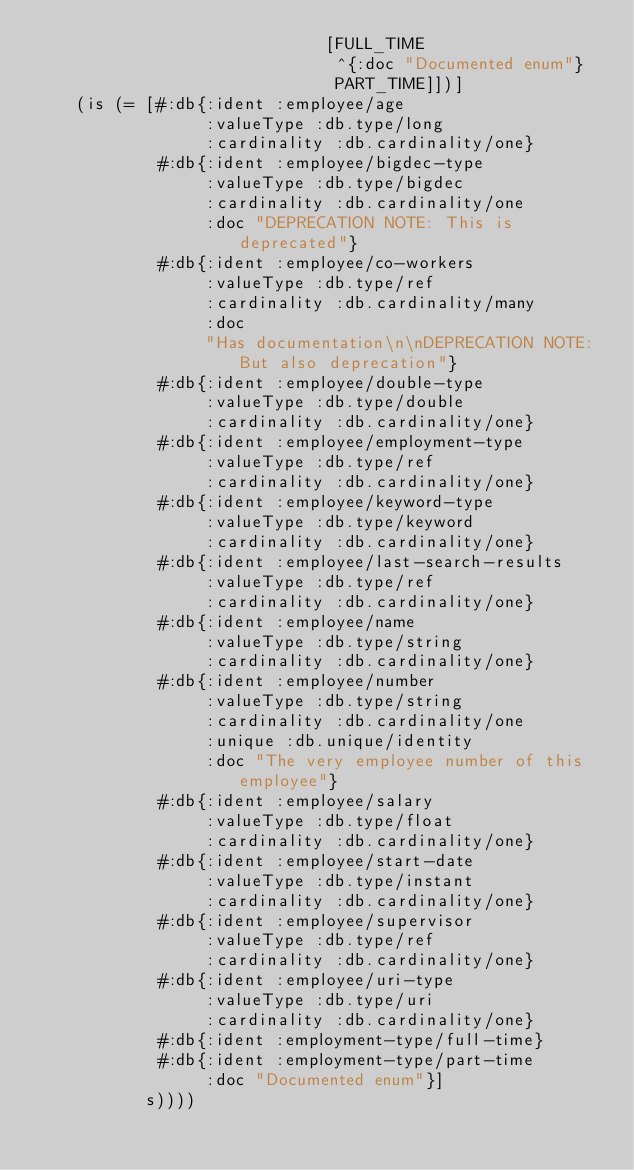Convert code to text. <code><loc_0><loc_0><loc_500><loc_500><_Clojure_>                             [FULL_TIME
                              ^{:doc "Documented enum"}
                              PART_TIME]])]
    (is (= [#:db{:ident :employee/age
                 :valueType :db.type/long
                 :cardinality :db.cardinality/one}
            #:db{:ident :employee/bigdec-type
                 :valueType :db.type/bigdec
                 :cardinality :db.cardinality/one
                 :doc "DEPRECATION NOTE: This is deprecated"}
            #:db{:ident :employee/co-workers
                 :valueType :db.type/ref
                 :cardinality :db.cardinality/many
                 :doc
                 "Has documentation\n\nDEPRECATION NOTE: But also deprecation"}
            #:db{:ident :employee/double-type
                 :valueType :db.type/double
                 :cardinality :db.cardinality/one}
            #:db{:ident :employee/employment-type
                 :valueType :db.type/ref
                 :cardinality :db.cardinality/one}
            #:db{:ident :employee/keyword-type
                 :valueType :db.type/keyword
                 :cardinality :db.cardinality/one}
            #:db{:ident :employee/last-search-results
                 :valueType :db.type/ref
                 :cardinality :db.cardinality/one}
            #:db{:ident :employee/name
                 :valueType :db.type/string
                 :cardinality :db.cardinality/one}
            #:db{:ident :employee/number
                 :valueType :db.type/string
                 :cardinality :db.cardinality/one
                 :unique :db.unique/identity
                 :doc "The very employee number of this employee"}
            #:db{:ident :employee/salary
                 :valueType :db.type/float
                 :cardinality :db.cardinality/one}
            #:db{:ident :employee/start-date
                 :valueType :db.type/instant
                 :cardinality :db.cardinality/one}
            #:db{:ident :employee/supervisor
                 :valueType :db.type/ref
                 :cardinality :db.cardinality/one}
            #:db{:ident :employee/uri-type
                 :valueType :db.type/uri
                 :cardinality :db.cardinality/one}
            #:db{:ident :employment-type/full-time}
            #:db{:ident :employment-type/part-time
                 :doc "Documented enum"}]
           s))))
</code> 